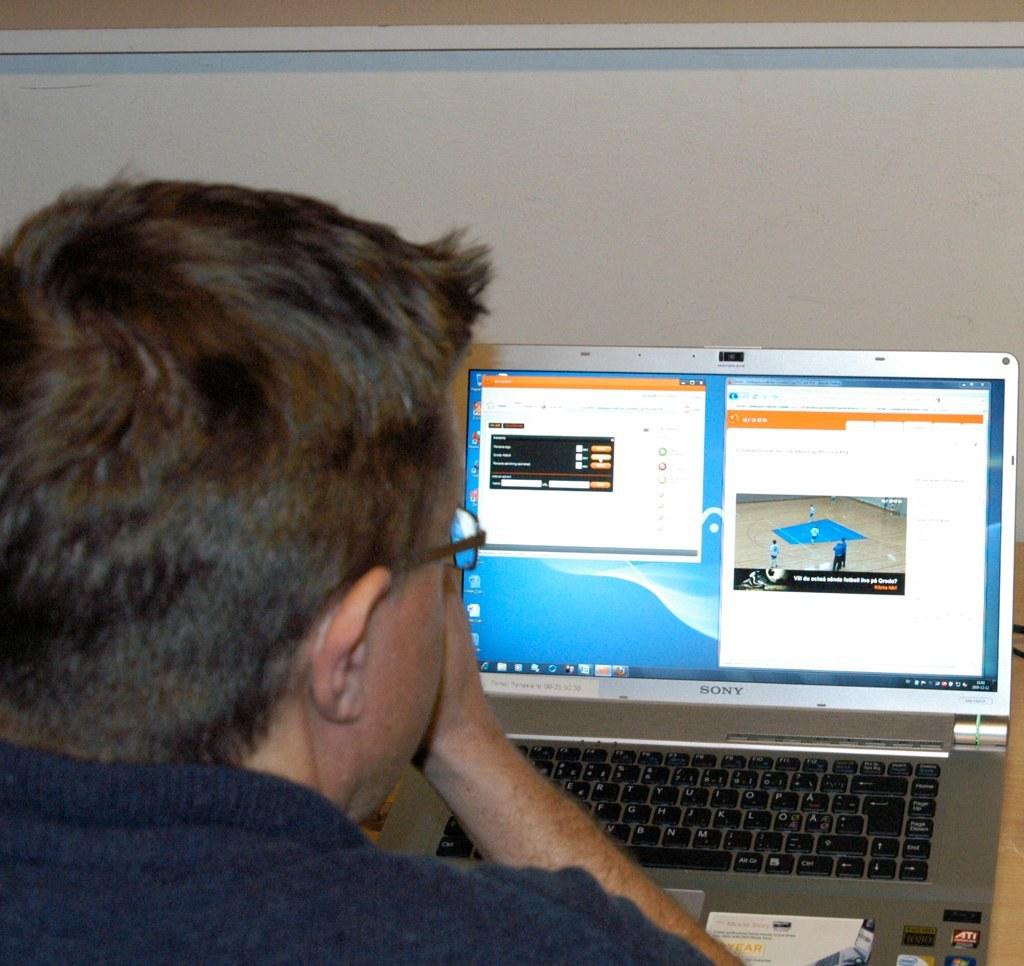What company manufactured the laptop?
Provide a short and direct response. Sony. 